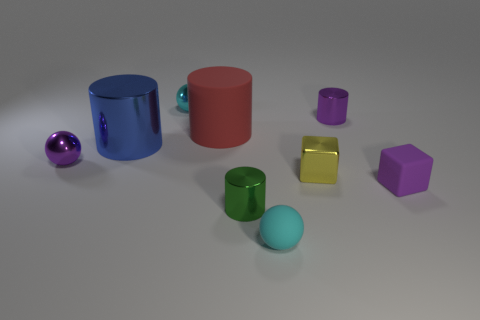Do the big metallic cylinder and the big cylinder behind the blue metal cylinder have the same color?
Your answer should be compact. No. What is the material of the sphere that is the same color as the matte block?
Ensure brevity in your answer.  Metal. Are there any other things that have the same shape as the red object?
Keep it short and to the point. Yes. There is a small purple thing that is on the right side of the purple metallic object that is right of the tiny thing to the left of the big metal thing; what is its shape?
Give a very brief answer. Cube. What shape is the big red matte thing?
Offer a very short reply. Cylinder. There is a tiny matte object on the right side of the small purple cylinder; what is its color?
Keep it short and to the point. Purple. There is a object that is to the right of the purple cylinder; is it the same size as the red rubber object?
Your answer should be compact. No. There is a blue thing that is the same shape as the large red matte object; what size is it?
Provide a succinct answer. Large. Does the large red matte object have the same shape as the cyan rubber object?
Keep it short and to the point. No. Is the number of cylinders behind the yellow thing less than the number of objects that are to the left of the purple rubber cube?
Your answer should be very brief. Yes. 